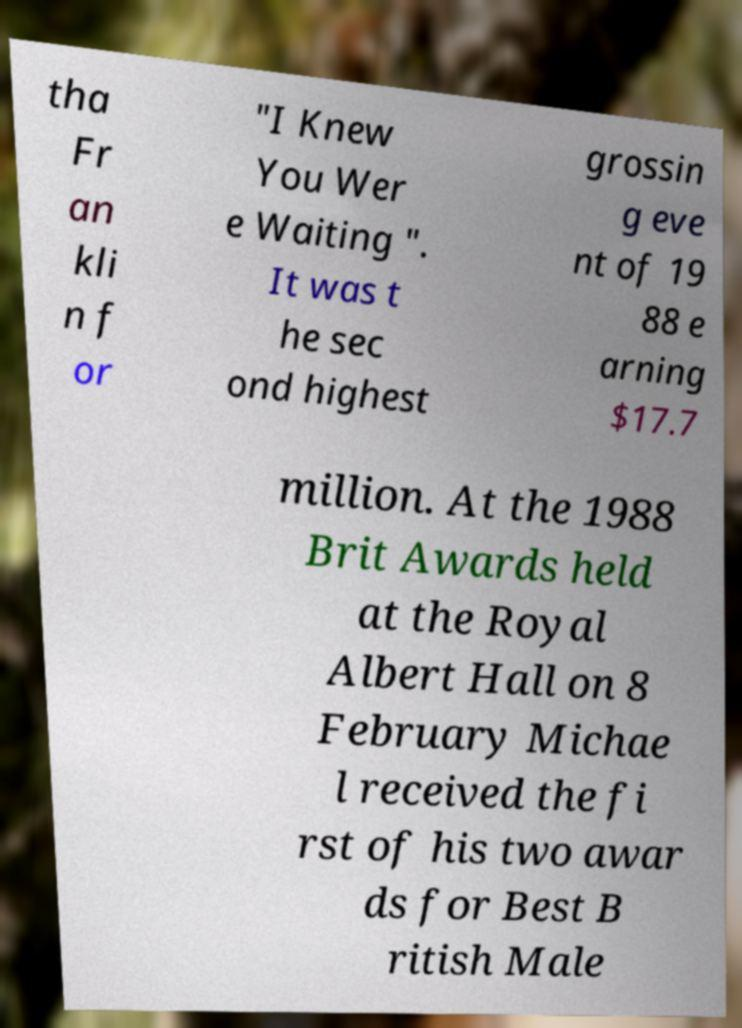Please identify and transcribe the text found in this image. tha Fr an kli n f or "I Knew You Wer e Waiting ". It was t he sec ond highest grossin g eve nt of 19 88 e arning $17.7 million. At the 1988 Brit Awards held at the Royal Albert Hall on 8 February Michae l received the fi rst of his two awar ds for Best B ritish Male 